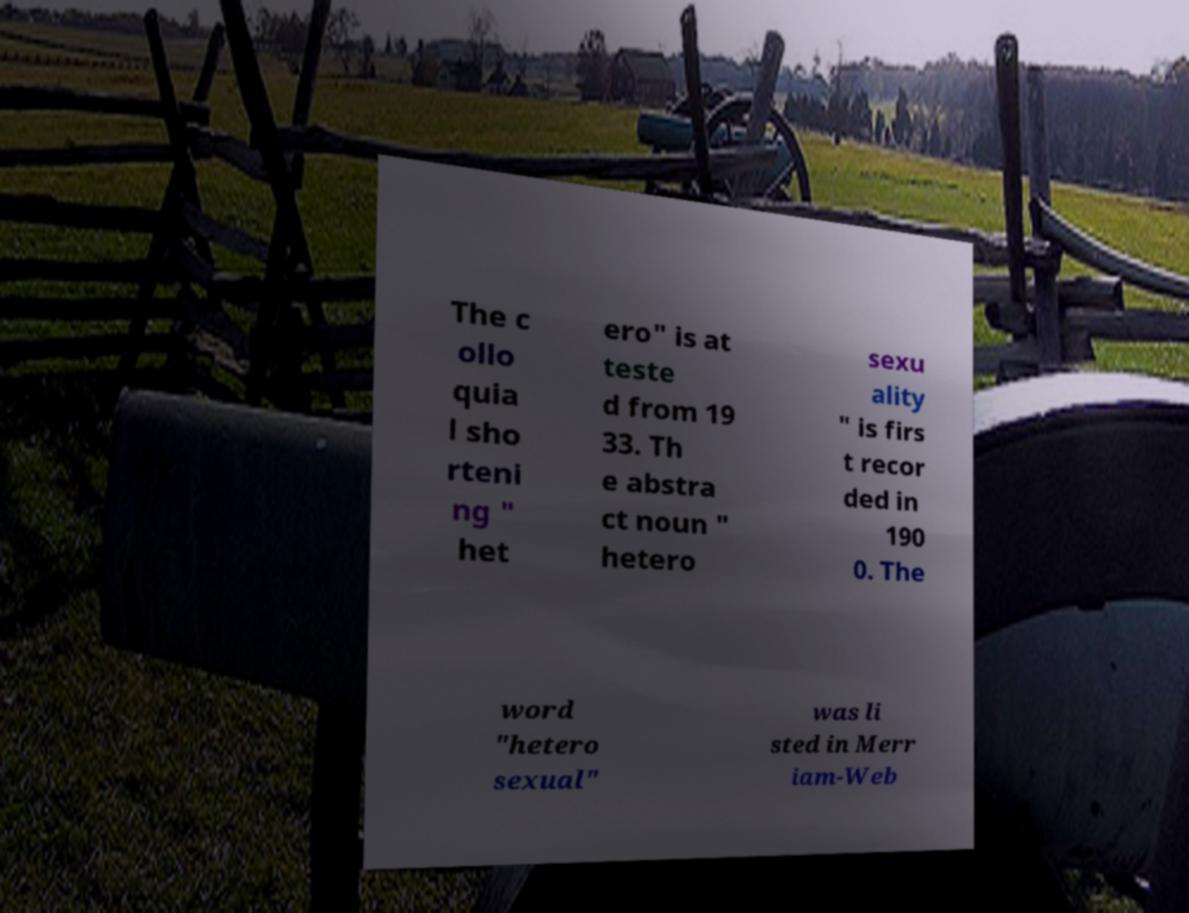There's text embedded in this image that I need extracted. Can you transcribe it verbatim? The c ollo quia l sho rteni ng " het ero" is at teste d from 19 33. Th e abstra ct noun " hetero sexu ality " is firs t recor ded in 190 0. The word "hetero sexual" was li sted in Merr iam-Web 